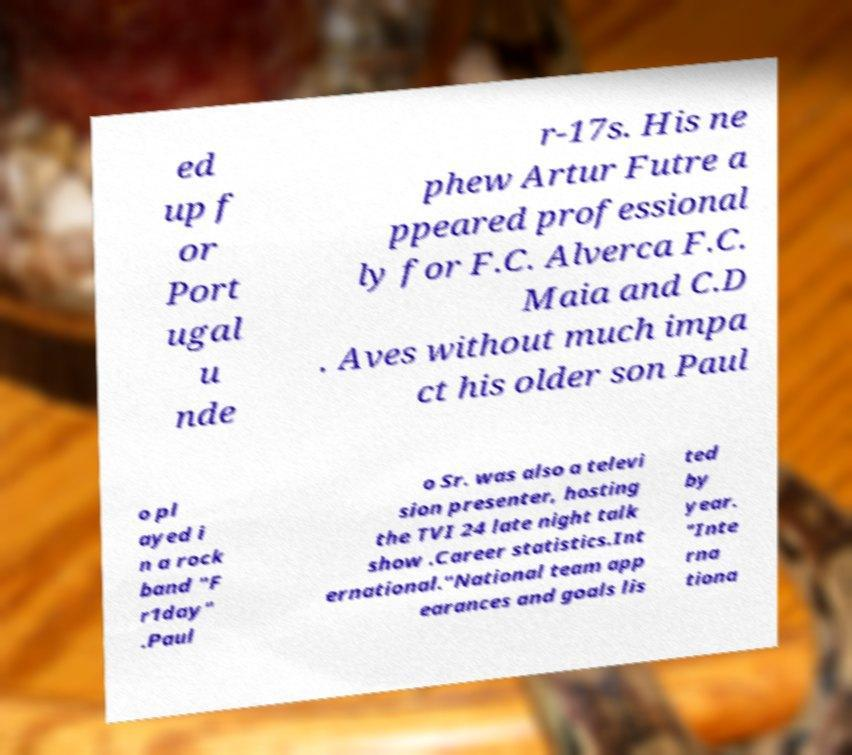What messages or text are displayed in this image? I need them in a readable, typed format. ed up f or Port ugal u nde r-17s. His ne phew Artur Futre a ppeared professional ly for F.C. Alverca F.C. Maia and C.D . Aves without much impa ct his older son Paul o pl ayed i n a rock band "F r1day" .Paul o Sr. was also a televi sion presenter, hosting the TVI 24 late night talk show .Career statistics.Int ernational."National team app earances and goals lis ted by year. "Inte rna tiona 